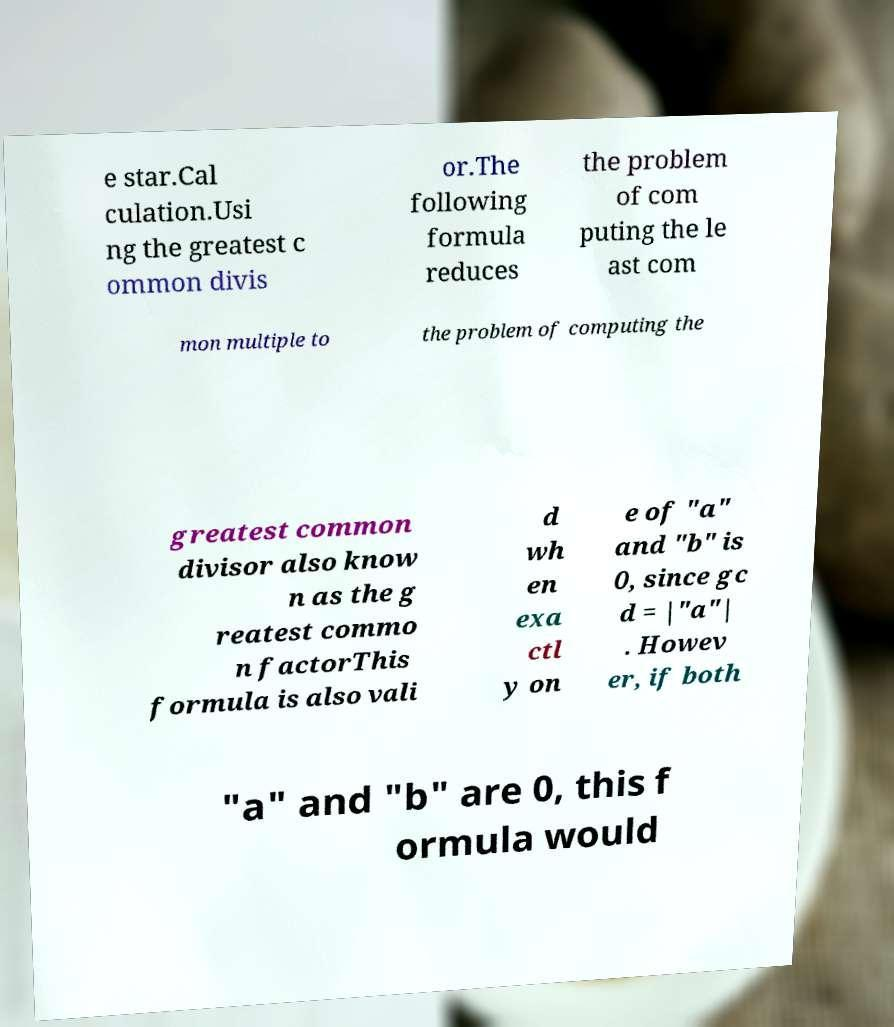I need the written content from this picture converted into text. Can you do that? e star.Cal culation.Usi ng the greatest c ommon divis or.The following formula reduces the problem of com puting the le ast com mon multiple to the problem of computing the greatest common divisor also know n as the g reatest commo n factorThis formula is also vali d wh en exa ctl y on e of "a" and "b" is 0, since gc d = |"a"| . Howev er, if both "a" and "b" are 0, this f ormula would 